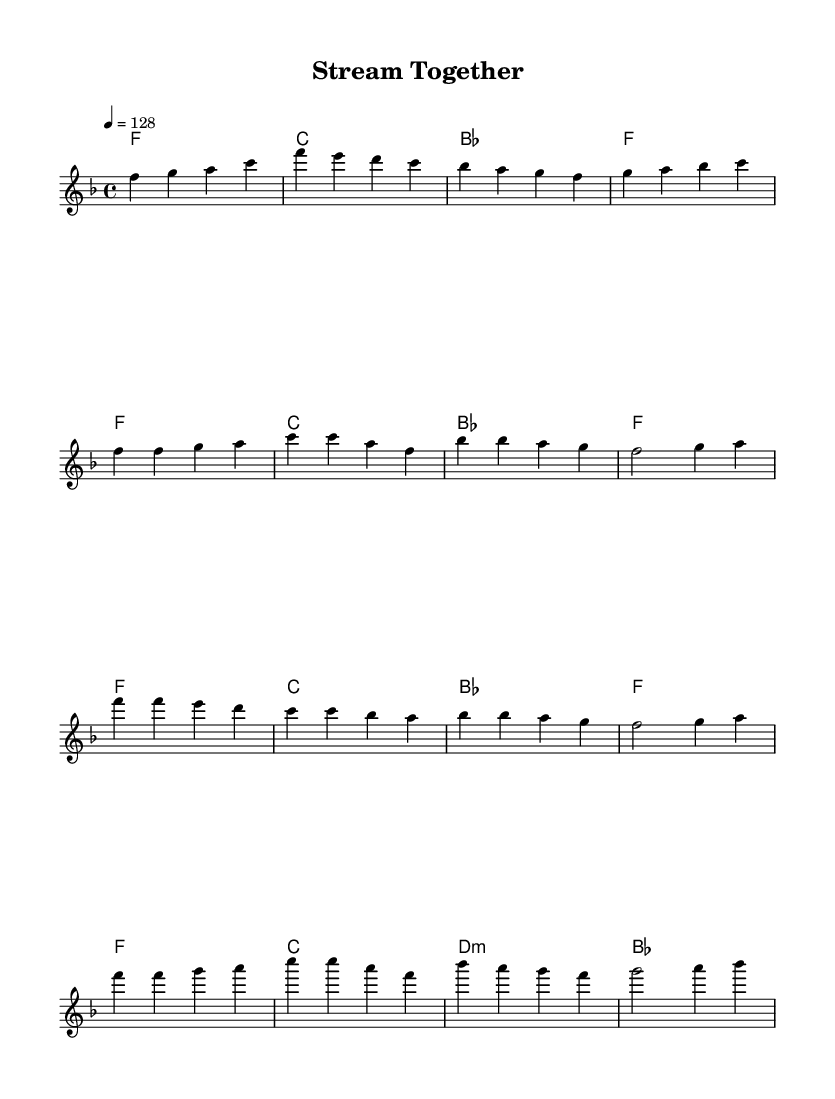What is the key signature of this music? The key signature is indicated by the number of sharps or flats shown at the beginning of the staff. In this sheet music, the signature shows one flat (B flat) which indicates the key of F major.
Answer: F major What is the time signature of this music? The time signature is shown at the beginning of the score, indicating how many beats are in each measure. This piece has a time signature of 4/4, meaning there are four beats per measure.
Answer: 4/4 What is the tempo marking for this piece? The tempo is specified in beats per minute (BPM) and found at the beginning of the score. Here, it indicates a tempo of 128 beats per minute, which is typical for dance music.
Answer: 128 How many measures are in the chorus section? To find the number of measures, I count how many times a measure is notated in the chorus section of the music. The chorus consists of six measures.
Answer: 6 What chord starts the chorus of the piece? The first chord of the chorus is identified in the chord names above the staff. It shows an F major chord at the beginning of the chorus section.
Answer: F What is the concluding chord of the musical piece? The last line of the score indicates the final chord which appears at the end of the chorus. The score specifies a B flat chord as the concluding element.
Answer: B flat Which section of the music has the same chord progression as the verse? By comparing the chord sections in the score, both the verse and the chorus begin with the same progression, repeating after the first few measures, thus they share the initial three chords.
Answer: Verse 